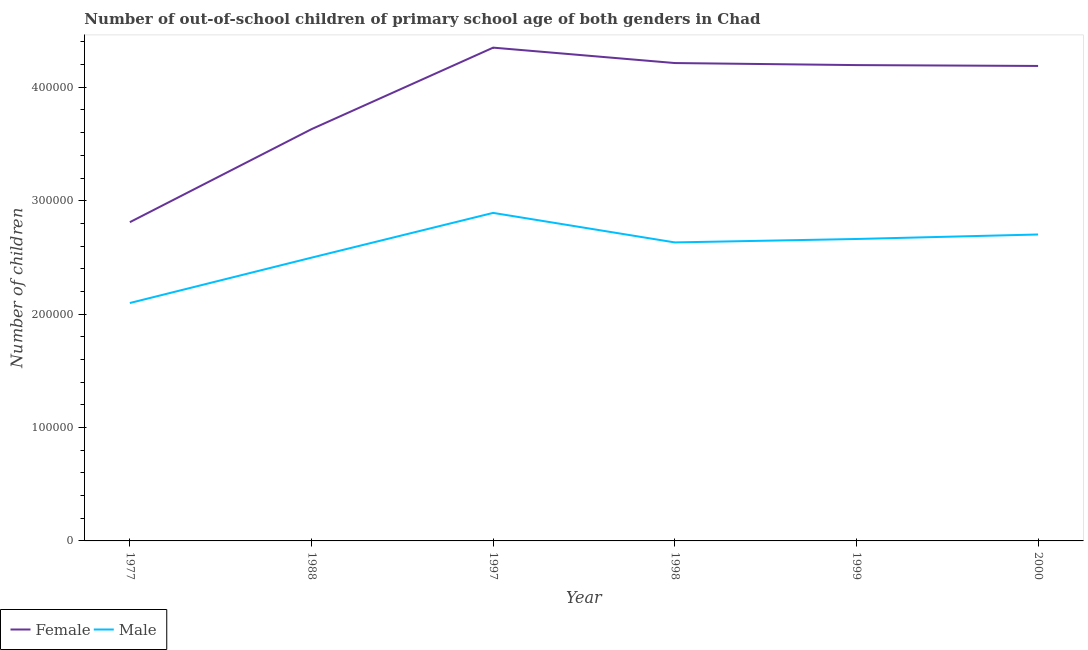How many different coloured lines are there?
Your answer should be very brief. 2. Is the number of lines equal to the number of legend labels?
Your answer should be compact. Yes. What is the number of male out-of-school students in 1998?
Make the answer very short. 2.63e+05. Across all years, what is the maximum number of female out-of-school students?
Your answer should be compact. 4.35e+05. Across all years, what is the minimum number of female out-of-school students?
Keep it short and to the point. 2.81e+05. In which year was the number of female out-of-school students minimum?
Your answer should be compact. 1977. What is the total number of female out-of-school students in the graph?
Give a very brief answer. 2.34e+06. What is the difference between the number of male out-of-school students in 1988 and that in 1999?
Offer a very short reply. -1.65e+04. What is the difference between the number of female out-of-school students in 2000 and the number of male out-of-school students in 1998?
Provide a succinct answer. 1.56e+05. What is the average number of female out-of-school students per year?
Provide a succinct answer. 3.90e+05. In the year 1998, what is the difference between the number of male out-of-school students and number of female out-of-school students?
Your response must be concise. -1.58e+05. What is the ratio of the number of male out-of-school students in 1977 to that in 1998?
Your response must be concise. 0.8. Is the number of male out-of-school students in 1988 less than that in 1998?
Your answer should be compact. Yes. Is the difference between the number of male out-of-school students in 1999 and 2000 greater than the difference between the number of female out-of-school students in 1999 and 2000?
Your answer should be compact. No. What is the difference between the highest and the second highest number of female out-of-school students?
Offer a terse response. 1.36e+04. What is the difference between the highest and the lowest number of male out-of-school students?
Your response must be concise. 7.95e+04. In how many years, is the number of female out-of-school students greater than the average number of female out-of-school students taken over all years?
Ensure brevity in your answer.  4. Is the sum of the number of male out-of-school students in 1977 and 1997 greater than the maximum number of female out-of-school students across all years?
Offer a very short reply. Yes. How many lines are there?
Ensure brevity in your answer.  2. How many legend labels are there?
Make the answer very short. 2. How are the legend labels stacked?
Keep it short and to the point. Horizontal. What is the title of the graph?
Give a very brief answer. Number of out-of-school children of primary school age of both genders in Chad. Does "Commercial service exports" appear as one of the legend labels in the graph?
Provide a short and direct response. No. What is the label or title of the Y-axis?
Provide a short and direct response. Number of children. What is the Number of children of Female in 1977?
Offer a very short reply. 2.81e+05. What is the Number of children in Male in 1977?
Provide a short and direct response. 2.10e+05. What is the Number of children in Female in 1988?
Offer a very short reply. 3.63e+05. What is the Number of children in Male in 1988?
Offer a very short reply. 2.50e+05. What is the Number of children of Female in 1997?
Your answer should be very brief. 4.35e+05. What is the Number of children of Male in 1997?
Provide a succinct answer. 2.89e+05. What is the Number of children in Female in 1998?
Give a very brief answer. 4.21e+05. What is the Number of children in Male in 1998?
Your answer should be compact. 2.63e+05. What is the Number of children in Female in 1999?
Your answer should be compact. 4.20e+05. What is the Number of children in Male in 1999?
Ensure brevity in your answer.  2.66e+05. What is the Number of children of Female in 2000?
Your response must be concise. 4.19e+05. What is the Number of children in Male in 2000?
Your response must be concise. 2.70e+05. Across all years, what is the maximum Number of children in Female?
Your answer should be compact. 4.35e+05. Across all years, what is the maximum Number of children in Male?
Your answer should be compact. 2.89e+05. Across all years, what is the minimum Number of children of Female?
Give a very brief answer. 2.81e+05. Across all years, what is the minimum Number of children in Male?
Make the answer very short. 2.10e+05. What is the total Number of children of Female in the graph?
Give a very brief answer. 2.34e+06. What is the total Number of children in Male in the graph?
Give a very brief answer. 1.55e+06. What is the difference between the Number of children of Female in 1977 and that in 1988?
Your answer should be compact. -8.20e+04. What is the difference between the Number of children of Male in 1977 and that in 1988?
Give a very brief answer. -4.00e+04. What is the difference between the Number of children of Female in 1977 and that in 1997?
Offer a very short reply. -1.54e+05. What is the difference between the Number of children in Male in 1977 and that in 1997?
Keep it short and to the point. -7.95e+04. What is the difference between the Number of children of Female in 1977 and that in 1998?
Offer a very short reply. -1.40e+05. What is the difference between the Number of children in Male in 1977 and that in 1998?
Provide a succinct answer. -5.34e+04. What is the difference between the Number of children of Female in 1977 and that in 1999?
Your answer should be compact. -1.39e+05. What is the difference between the Number of children of Male in 1977 and that in 1999?
Your answer should be compact. -5.65e+04. What is the difference between the Number of children of Female in 1977 and that in 2000?
Your answer should be very brief. -1.38e+05. What is the difference between the Number of children in Male in 1977 and that in 2000?
Make the answer very short. -6.04e+04. What is the difference between the Number of children in Female in 1988 and that in 1997?
Your response must be concise. -7.19e+04. What is the difference between the Number of children of Male in 1988 and that in 1997?
Your answer should be very brief. -3.95e+04. What is the difference between the Number of children of Female in 1988 and that in 1998?
Provide a short and direct response. -5.83e+04. What is the difference between the Number of children of Male in 1988 and that in 1998?
Your response must be concise. -1.34e+04. What is the difference between the Number of children of Female in 1988 and that in 1999?
Your answer should be compact. -5.65e+04. What is the difference between the Number of children of Male in 1988 and that in 1999?
Offer a terse response. -1.65e+04. What is the difference between the Number of children of Female in 1988 and that in 2000?
Your response must be concise. -5.57e+04. What is the difference between the Number of children in Male in 1988 and that in 2000?
Provide a short and direct response. -2.04e+04. What is the difference between the Number of children of Female in 1997 and that in 1998?
Offer a terse response. 1.36e+04. What is the difference between the Number of children of Male in 1997 and that in 1998?
Your answer should be very brief. 2.60e+04. What is the difference between the Number of children in Female in 1997 and that in 1999?
Your response must be concise. 1.54e+04. What is the difference between the Number of children of Male in 1997 and that in 1999?
Provide a short and direct response. 2.30e+04. What is the difference between the Number of children of Female in 1997 and that in 2000?
Offer a terse response. 1.61e+04. What is the difference between the Number of children in Male in 1997 and that in 2000?
Provide a succinct answer. 1.90e+04. What is the difference between the Number of children in Female in 1998 and that in 1999?
Keep it short and to the point. 1805. What is the difference between the Number of children in Male in 1998 and that in 1999?
Your answer should be compact. -3034. What is the difference between the Number of children in Female in 1998 and that in 2000?
Offer a very short reply. 2562. What is the difference between the Number of children in Male in 1998 and that in 2000?
Give a very brief answer. -7003. What is the difference between the Number of children of Female in 1999 and that in 2000?
Make the answer very short. 757. What is the difference between the Number of children in Male in 1999 and that in 2000?
Provide a short and direct response. -3969. What is the difference between the Number of children of Female in 1977 and the Number of children of Male in 1988?
Give a very brief answer. 3.13e+04. What is the difference between the Number of children of Female in 1977 and the Number of children of Male in 1997?
Offer a terse response. -8192. What is the difference between the Number of children in Female in 1977 and the Number of children in Male in 1998?
Provide a succinct answer. 1.79e+04. What is the difference between the Number of children in Female in 1977 and the Number of children in Male in 1999?
Offer a very short reply. 1.48e+04. What is the difference between the Number of children of Female in 1977 and the Number of children of Male in 2000?
Your answer should be very brief. 1.08e+04. What is the difference between the Number of children in Female in 1988 and the Number of children in Male in 1997?
Provide a short and direct response. 7.38e+04. What is the difference between the Number of children of Female in 1988 and the Number of children of Male in 1998?
Your answer should be compact. 9.99e+04. What is the difference between the Number of children of Female in 1988 and the Number of children of Male in 1999?
Ensure brevity in your answer.  9.68e+04. What is the difference between the Number of children in Female in 1988 and the Number of children in Male in 2000?
Offer a very short reply. 9.29e+04. What is the difference between the Number of children in Female in 1997 and the Number of children in Male in 1998?
Keep it short and to the point. 1.72e+05. What is the difference between the Number of children in Female in 1997 and the Number of children in Male in 1999?
Your answer should be compact. 1.69e+05. What is the difference between the Number of children of Female in 1997 and the Number of children of Male in 2000?
Offer a very short reply. 1.65e+05. What is the difference between the Number of children of Female in 1998 and the Number of children of Male in 1999?
Offer a very short reply. 1.55e+05. What is the difference between the Number of children in Female in 1998 and the Number of children in Male in 2000?
Provide a short and direct response. 1.51e+05. What is the difference between the Number of children of Female in 1999 and the Number of children of Male in 2000?
Keep it short and to the point. 1.49e+05. What is the average Number of children of Female per year?
Keep it short and to the point. 3.90e+05. What is the average Number of children in Male per year?
Offer a very short reply. 2.58e+05. In the year 1977, what is the difference between the Number of children in Female and Number of children in Male?
Give a very brief answer. 7.13e+04. In the year 1988, what is the difference between the Number of children of Female and Number of children of Male?
Give a very brief answer. 1.13e+05. In the year 1997, what is the difference between the Number of children of Female and Number of children of Male?
Make the answer very short. 1.46e+05. In the year 1998, what is the difference between the Number of children in Female and Number of children in Male?
Your answer should be very brief. 1.58e+05. In the year 1999, what is the difference between the Number of children in Female and Number of children in Male?
Ensure brevity in your answer.  1.53e+05. In the year 2000, what is the difference between the Number of children in Female and Number of children in Male?
Make the answer very short. 1.49e+05. What is the ratio of the Number of children in Female in 1977 to that in 1988?
Give a very brief answer. 0.77. What is the ratio of the Number of children of Male in 1977 to that in 1988?
Keep it short and to the point. 0.84. What is the ratio of the Number of children in Female in 1977 to that in 1997?
Provide a short and direct response. 0.65. What is the ratio of the Number of children in Male in 1977 to that in 1997?
Make the answer very short. 0.73. What is the ratio of the Number of children in Female in 1977 to that in 1998?
Offer a terse response. 0.67. What is the ratio of the Number of children in Male in 1977 to that in 1998?
Give a very brief answer. 0.8. What is the ratio of the Number of children of Female in 1977 to that in 1999?
Ensure brevity in your answer.  0.67. What is the ratio of the Number of children in Male in 1977 to that in 1999?
Your answer should be compact. 0.79. What is the ratio of the Number of children in Female in 1977 to that in 2000?
Offer a terse response. 0.67. What is the ratio of the Number of children in Male in 1977 to that in 2000?
Ensure brevity in your answer.  0.78. What is the ratio of the Number of children of Female in 1988 to that in 1997?
Your response must be concise. 0.83. What is the ratio of the Number of children in Male in 1988 to that in 1997?
Provide a succinct answer. 0.86. What is the ratio of the Number of children in Female in 1988 to that in 1998?
Ensure brevity in your answer.  0.86. What is the ratio of the Number of children of Male in 1988 to that in 1998?
Your answer should be very brief. 0.95. What is the ratio of the Number of children in Female in 1988 to that in 1999?
Your answer should be compact. 0.87. What is the ratio of the Number of children of Male in 1988 to that in 1999?
Offer a terse response. 0.94. What is the ratio of the Number of children of Female in 1988 to that in 2000?
Make the answer very short. 0.87. What is the ratio of the Number of children of Male in 1988 to that in 2000?
Provide a succinct answer. 0.92. What is the ratio of the Number of children in Female in 1997 to that in 1998?
Ensure brevity in your answer.  1.03. What is the ratio of the Number of children in Male in 1997 to that in 1998?
Provide a short and direct response. 1.1. What is the ratio of the Number of children in Female in 1997 to that in 1999?
Make the answer very short. 1.04. What is the ratio of the Number of children of Male in 1997 to that in 1999?
Make the answer very short. 1.09. What is the ratio of the Number of children in Male in 1997 to that in 2000?
Provide a short and direct response. 1.07. What is the ratio of the Number of children in Male in 1998 to that in 1999?
Your answer should be compact. 0.99. What is the ratio of the Number of children of Female in 1998 to that in 2000?
Give a very brief answer. 1.01. What is the ratio of the Number of children in Male in 1998 to that in 2000?
Provide a succinct answer. 0.97. What is the difference between the highest and the second highest Number of children in Female?
Provide a short and direct response. 1.36e+04. What is the difference between the highest and the second highest Number of children in Male?
Keep it short and to the point. 1.90e+04. What is the difference between the highest and the lowest Number of children in Female?
Your answer should be compact. 1.54e+05. What is the difference between the highest and the lowest Number of children of Male?
Your response must be concise. 7.95e+04. 